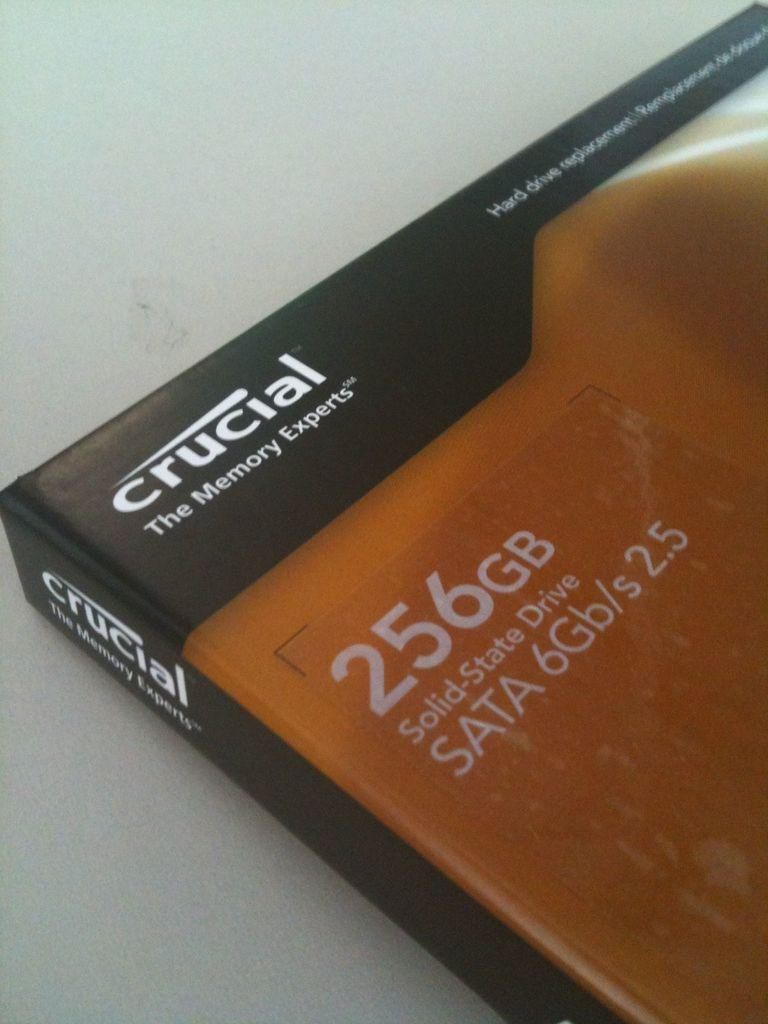<image>
Share a concise interpretation of the image provided. A box has the brand name crucial in the corner. 